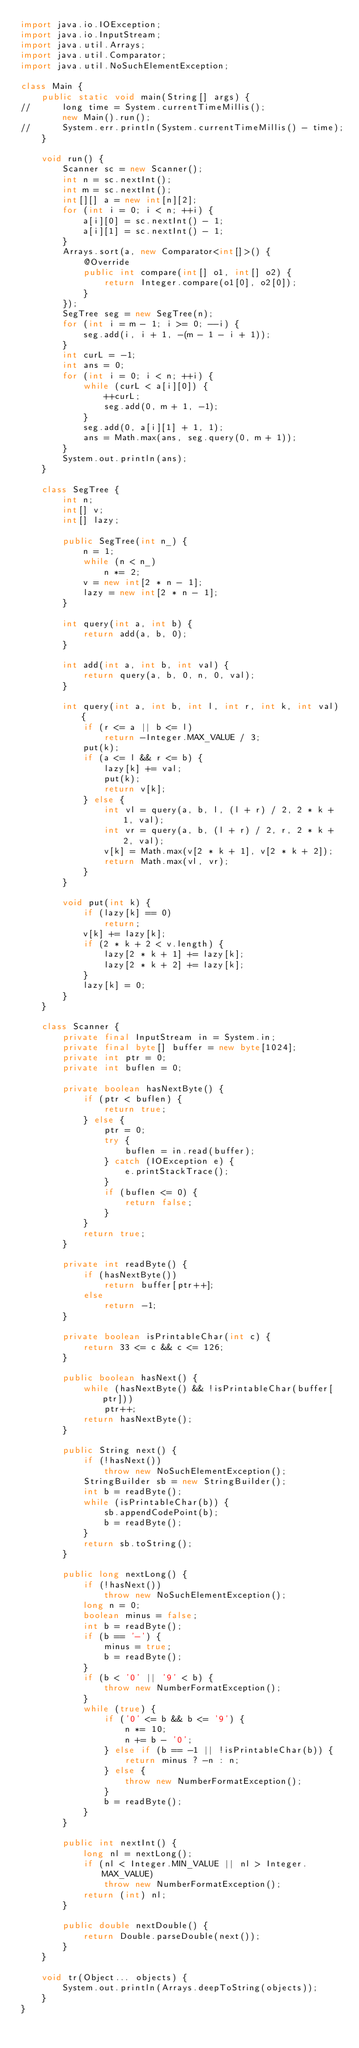<code> <loc_0><loc_0><loc_500><loc_500><_Java_>import java.io.IOException;
import java.io.InputStream;
import java.util.Arrays;
import java.util.Comparator;
import java.util.NoSuchElementException;

class Main {
	public static void main(String[] args) {
//		long time = System.currentTimeMillis();
		new Main().run();
//		System.err.println(System.currentTimeMillis() - time);
	}

	void run() {
		Scanner sc = new Scanner();
		int n = sc.nextInt();
		int m = sc.nextInt();
		int[][] a = new int[n][2];
		for (int i = 0; i < n; ++i) {
			a[i][0] = sc.nextInt() - 1;
			a[i][1] = sc.nextInt() - 1;
		}
		Arrays.sort(a, new Comparator<int[]>() {
			@Override
			public int compare(int[] o1, int[] o2) {
				return Integer.compare(o1[0], o2[0]);
			}
		});
		SegTree seg = new SegTree(n);
		for (int i = m - 1; i >= 0; --i) {
			seg.add(i, i + 1, -(m - 1 - i + 1));
		}
		int curL = -1;
		int ans = 0;
		for (int i = 0; i < n; ++i) {
			while (curL < a[i][0]) {
				++curL;
				seg.add(0, m + 1, -1);
			}
			seg.add(0, a[i][1] + 1, 1);
			ans = Math.max(ans, seg.query(0, m + 1));
		}
		System.out.println(ans);
	}

	class SegTree {
		int n;
		int[] v;
		int[] lazy;

		public SegTree(int n_) {
			n = 1;
			while (n < n_)
				n *= 2;
			v = new int[2 * n - 1];
			lazy = new int[2 * n - 1];
		}

		int query(int a, int b) {
			return add(a, b, 0);
		}

		int add(int a, int b, int val) {
			return query(a, b, 0, n, 0, val);
		}

		int query(int a, int b, int l, int r, int k, int val) {
			if (r <= a || b <= l)
				return -Integer.MAX_VALUE / 3;
			put(k);
			if (a <= l && r <= b) {
				lazy[k] += val;
				put(k);
				return v[k];
			} else {
				int vl = query(a, b, l, (l + r) / 2, 2 * k + 1, val);
				int vr = query(a, b, (l + r) / 2, r, 2 * k + 2, val);
				v[k] = Math.max(v[2 * k + 1], v[2 * k + 2]);
				return Math.max(vl, vr);
			}
		}

		void put(int k) {
			if (lazy[k] == 0)
				return;
			v[k] += lazy[k];
			if (2 * k + 2 < v.length) {
				lazy[2 * k + 1] += lazy[k];
				lazy[2 * k + 2] += lazy[k];
			}
			lazy[k] = 0;
		}
	}

	class Scanner {
		private final InputStream in = System.in;
		private final byte[] buffer = new byte[1024];
		private int ptr = 0;
		private int buflen = 0;

		private boolean hasNextByte() {
			if (ptr < buflen) {
				return true;
			} else {
				ptr = 0;
				try {
					buflen = in.read(buffer);
				} catch (IOException e) {
					e.printStackTrace();
				}
				if (buflen <= 0) {
					return false;
				}
			}
			return true;
		}

		private int readByte() {
			if (hasNextByte())
				return buffer[ptr++];
			else
				return -1;
		}

		private boolean isPrintableChar(int c) {
			return 33 <= c && c <= 126;
		}

		public boolean hasNext() {
			while (hasNextByte() && !isPrintableChar(buffer[ptr]))
				ptr++;
			return hasNextByte();
		}

		public String next() {
			if (!hasNext())
				throw new NoSuchElementException();
			StringBuilder sb = new StringBuilder();
			int b = readByte();
			while (isPrintableChar(b)) {
				sb.appendCodePoint(b);
				b = readByte();
			}
			return sb.toString();
		}

		public long nextLong() {
			if (!hasNext())
				throw new NoSuchElementException();
			long n = 0;
			boolean minus = false;
			int b = readByte();
			if (b == '-') {
				minus = true;
				b = readByte();
			}
			if (b < '0' || '9' < b) {
				throw new NumberFormatException();
			}
			while (true) {
				if ('0' <= b && b <= '9') {
					n *= 10;
					n += b - '0';
				} else if (b == -1 || !isPrintableChar(b)) {
					return minus ? -n : n;
				} else {
					throw new NumberFormatException();
				}
				b = readByte();
			}
		}

		public int nextInt() {
			long nl = nextLong();
			if (nl < Integer.MIN_VALUE || nl > Integer.MAX_VALUE)
				throw new NumberFormatException();
			return (int) nl;
		}

		public double nextDouble() {
			return Double.parseDouble(next());
		}
	}

	void tr(Object... objects) {
		System.out.println(Arrays.deepToString(objects));
	}
}</code> 